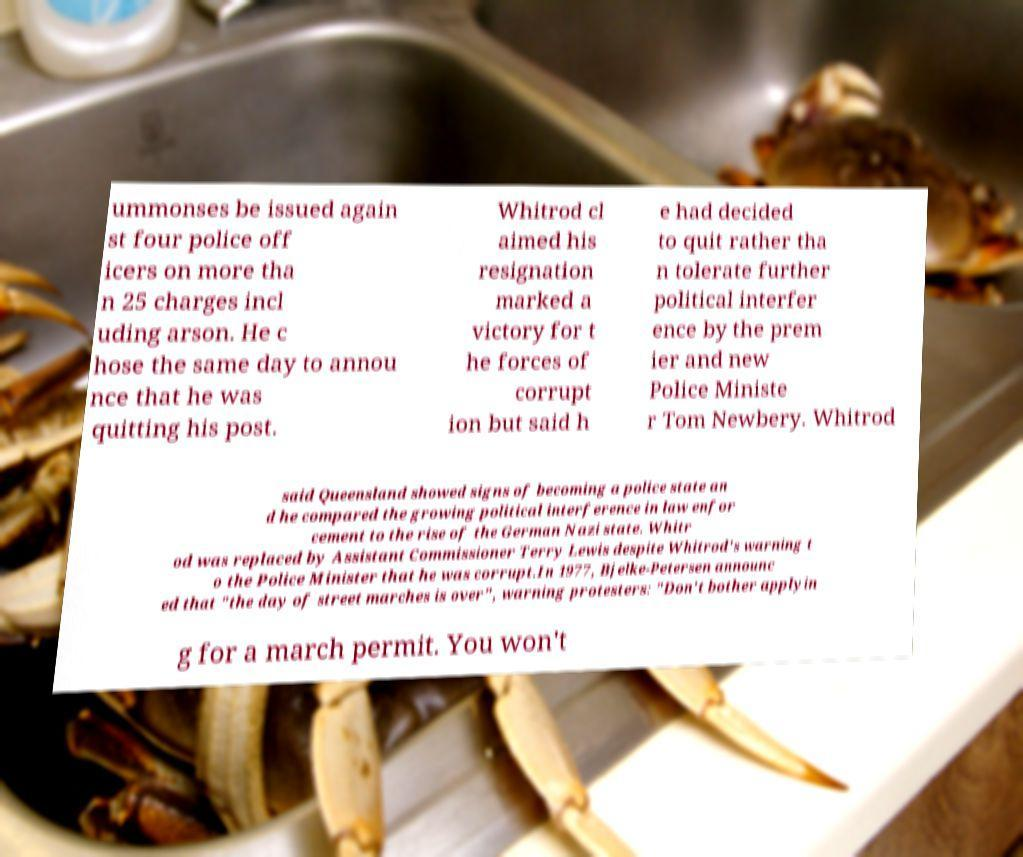What messages or text are displayed in this image? I need them in a readable, typed format. ummonses be issued again st four police off icers on more tha n 25 charges incl uding arson. He c hose the same day to annou nce that he was quitting his post. Whitrod cl aimed his resignation marked a victory for t he forces of corrupt ion but said h e had decided to quit rather tha n tolerate further political interfer ence by the prem ier and new Police Ministe r Tom Newbery. Whitrod said Queensland showed signs of becoming a police state an d he compared the growing political interference in law enfor cement to the rise of the German Nazi state. Whitr od was replaced by Assistant Commissioner Terry Lewis despite Whitrod's warning t o the Police Minister that he was corrupt.In 1977, Bjelke-Petersen announc ed that "the day of street marches is over", warning protesters: "Don't bother applyin g for a march permit. You won't 